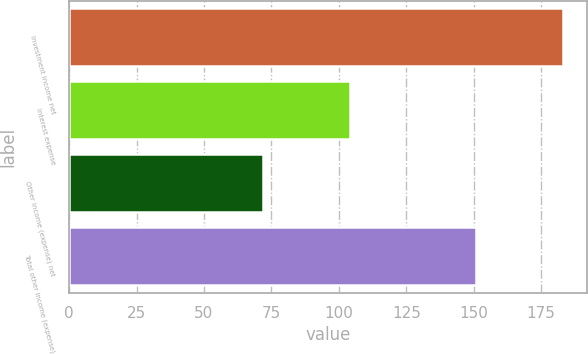Convert chart to OTSL. <chart><loc_0><loc_0><loc_500><loc_500><bar_chart><fcel>Investment income net<fcel>Interest expense<fcel>Other income (expense) net<fcel>Total other income (expense)<nl><fcel>183<fcel>104<fcel>72<fcel>151<nl></chart> 